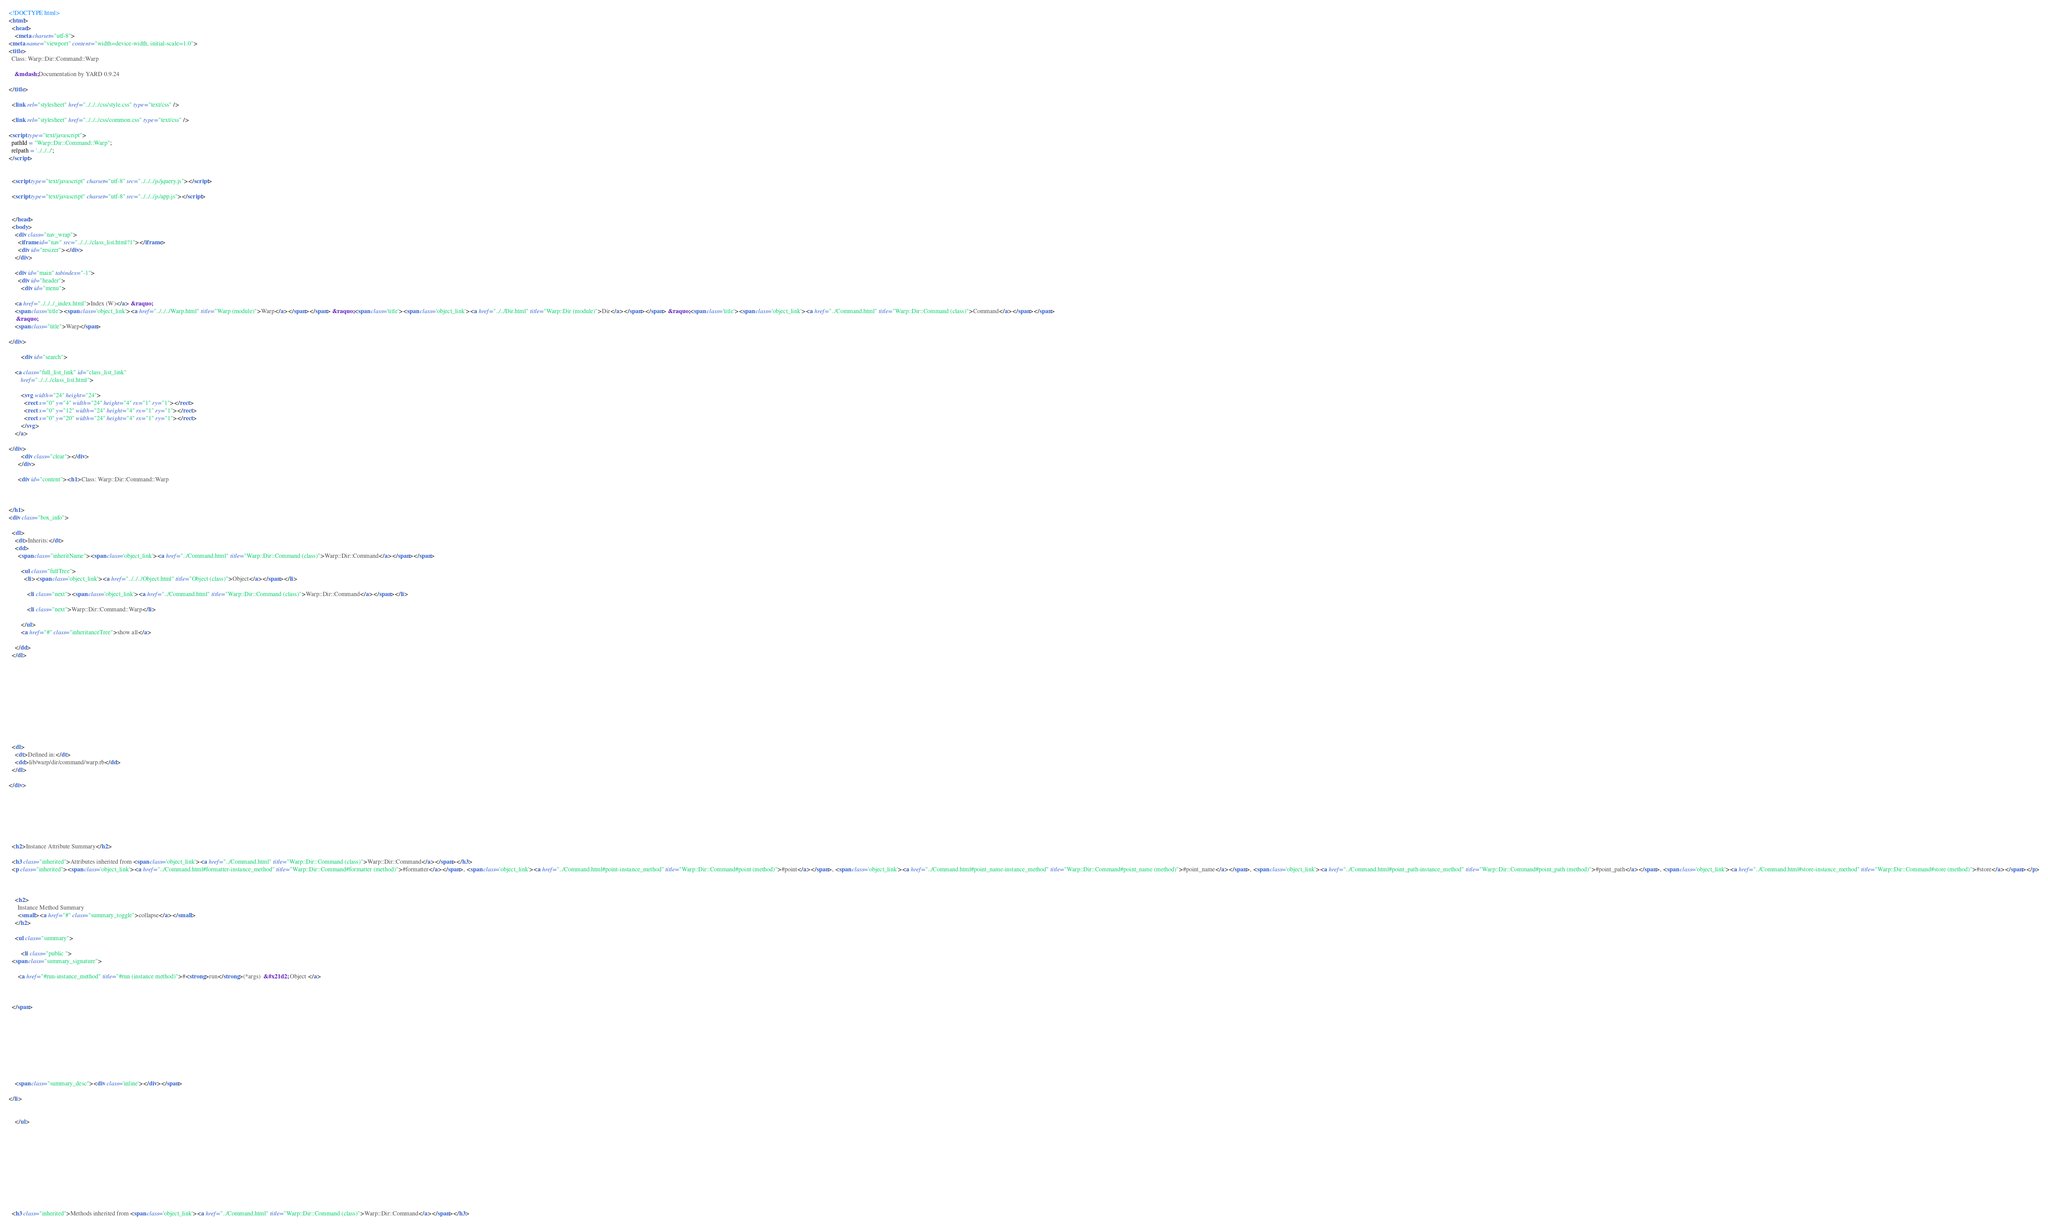<code> <loc_0><loc_0><loc_500><loc_500><_HTML_><!DOCTYPE html>
<html>
  <head>
    <meta charset="utf-8">
<meta name="viewport" content="width=device-width, initial-scale=1.0">
<title>
  Class: Warp::Dir::Command::Warp
  
    &mdash; Documentation by YARD 0.9.24
  
</title>

  <link rel="stylesheet" href="../../../css/style.css" type="text/css" />

  <link rel="stylesheet" href="../../../css/common.css" type="text/css" />

<script type="text/javascript">
  pathId = "Warp::Dir::Command::Warp";
  relpath = '../../../';
</script>


  <script type="text/javascript" charset="utf-8" src="../../../js/jquery.js"></script>

  <script type="text/javascript" charset="utf-8" src="../../../js/app.js"></script>


  </head>
  <body>
    <div class="nav_wrap">
      <iframe id="nav" src="../../../class_list.html?1"></iframe>
      <div id="resizer"></div>
    </div>

    <div id="main" tabindex="-1">
      <div id="header">
        <div id="menu">
  
    <a href="../../../_index.html">Index (W)</a> &raquo;
    <span class='title'><span class='object_link'><a href="../../../Warp.html" title="Warp (module)">Warp</a></span></span> &raquo; <span class='title'><span class='object_link'><a href="../../Dir.html" title="Warp::Dir (module)">Dir</a></span></span> &raquo; <span class='title'><span class='object_link'><a href="../Command.html" title="Warp::Dir::Command (class)">Command</a></span></span>
     &raquo; 
    <span class="title">Warp</span>
  
</div>

        <div id="search">
  
    <a class="full_list_link" id="class_list_link"
        href="../../../class_list.html">

        <svg width="24" height="24">
          <rect x="0" y="4" width="24" height="4" rx="1" ry="1"></rect>
          <rect x="0" y="12" width="24" height="4" rx="1" ry="1"></rect>
          <rect x="0" y="20" width="24" height="4" rx="1" ry="1"></rect>
        </svg>
    </a>
  
</div>
        <div class="clear"></div>
      </div>

      <div id="content"><h1>Class: Warp::Dir::Command::Warp
  
  
  
</h1>
<div class="box_info">
  
  <dl>
    <dt>Inherits:</dt>
    <dd>
      <span class="inheritName"><span class='object_link'><a href="../Command.html" title="Warp::Dir::Command (class)">Warp::Dir::Command</a></span></span>
      
        <ul class="fullTree">
          <li><span class='object_link'><a href="../../../Object.html" title="Object (class)">Object</a></span></li>
          
            <li class="next"><span class='object_link'><a href="../Command.html" title="Warp::Dir::Command (class)">Warp::Dir::Command</a></span></li>
          
            <li class="next">Warp::Dir::Command::Warp</li>
          
        </ul>
        <a href="#" class="inheritanceTree">show all</a>
      
    </dd>
  </dl>
  

  
  
  
  
  

  

  
  <dl>
    <dt>Defined in:</dt>
    <dd>lib/warp/dir/command/warp.rb</dd>
  </dl>
  
</div>







  <h2>Instance Attribute Summary</h2>
  
  <h3 class="inherited">Attributes inherited from <span class='object_link'><a href="../Command.html" title="Warp::Dir::Command (class)">Warp::Dir::Command</a></span></h3>
  <p class="inherited"><span class='object_link'><a href="../Command.html#formatter-instance_method" title="Warp::Dir::Command#formatter (method)">#formatter</a></span>, <span class='object_link'><a href="../Command.html#point-instance_method" title="Warp::Dir::Command#point (method)">#point</a></span>, <span class='object_link'><a href="../Command.html#point_name-instance_method" title="Warp::Dir::Command#point_name (method)">#point_name</a></span>, <span class='object_link'><a href="../Command.html#point_path-instance_method" title="Warp::Dir::Command#point_path (method)">#point_path</a></span>, <span class='object_link'><a href="../Command.html#store-instance_method" title="Warp::Dir::Command#store (method)">#store</a></span></p>


  
    <h2>
      Instance Method Summary
      <small><a href="#" class="summary_toggle">collapse</a></small>
    </h2>

    <ul class="summary">
      
        <li class="public ">
  <span class="summary_signature">
    
      <a href="#run-instance_method" title="#run (instance method)">#<strong>run</strong>(*args)  &#x21d2; Object </a>
    

    
  </span>
  
  
  
  
  
  
  

  
    <span class="summary_desc"><div class='inline'></div></span>
  
</li>

      
    </ul>
  


  
  
  
  
  
  
  
  
  <h3 class="inherited">Methods inherited from <span class='object_link'><a href="../Command.html" title="Warp::Dir::Command (class)">Warp::Dir::Command</a></span></h3></code> 